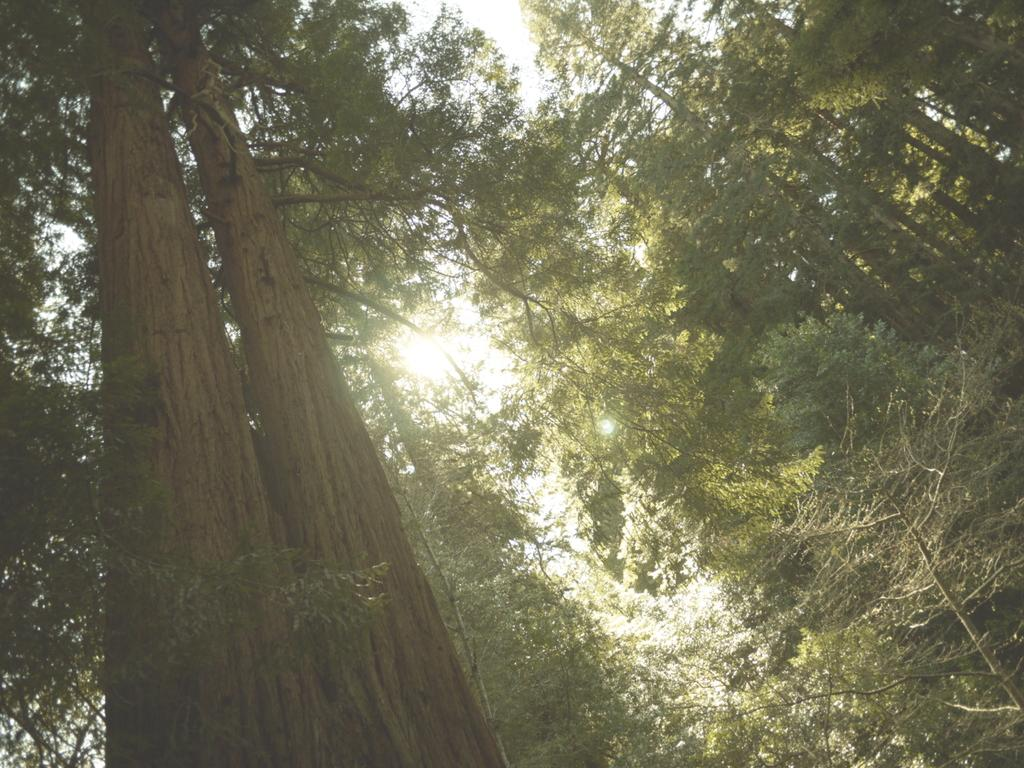What type of vegetation can be seen in the image? There are tall trees in the image. What part of the natural environment is visible in the image? The sky is visible in the image. How would you describe the sky in the image? The sky appears to be cloudy. What type of chin can be seen on the tall trees in the image? There is no chin present on the tall trees in the image; they are simply trees. Is there a locket hanging from the branches of the tall trees in the image? There is no locket present in the image; it only features tall trees and a cloudy sky. 